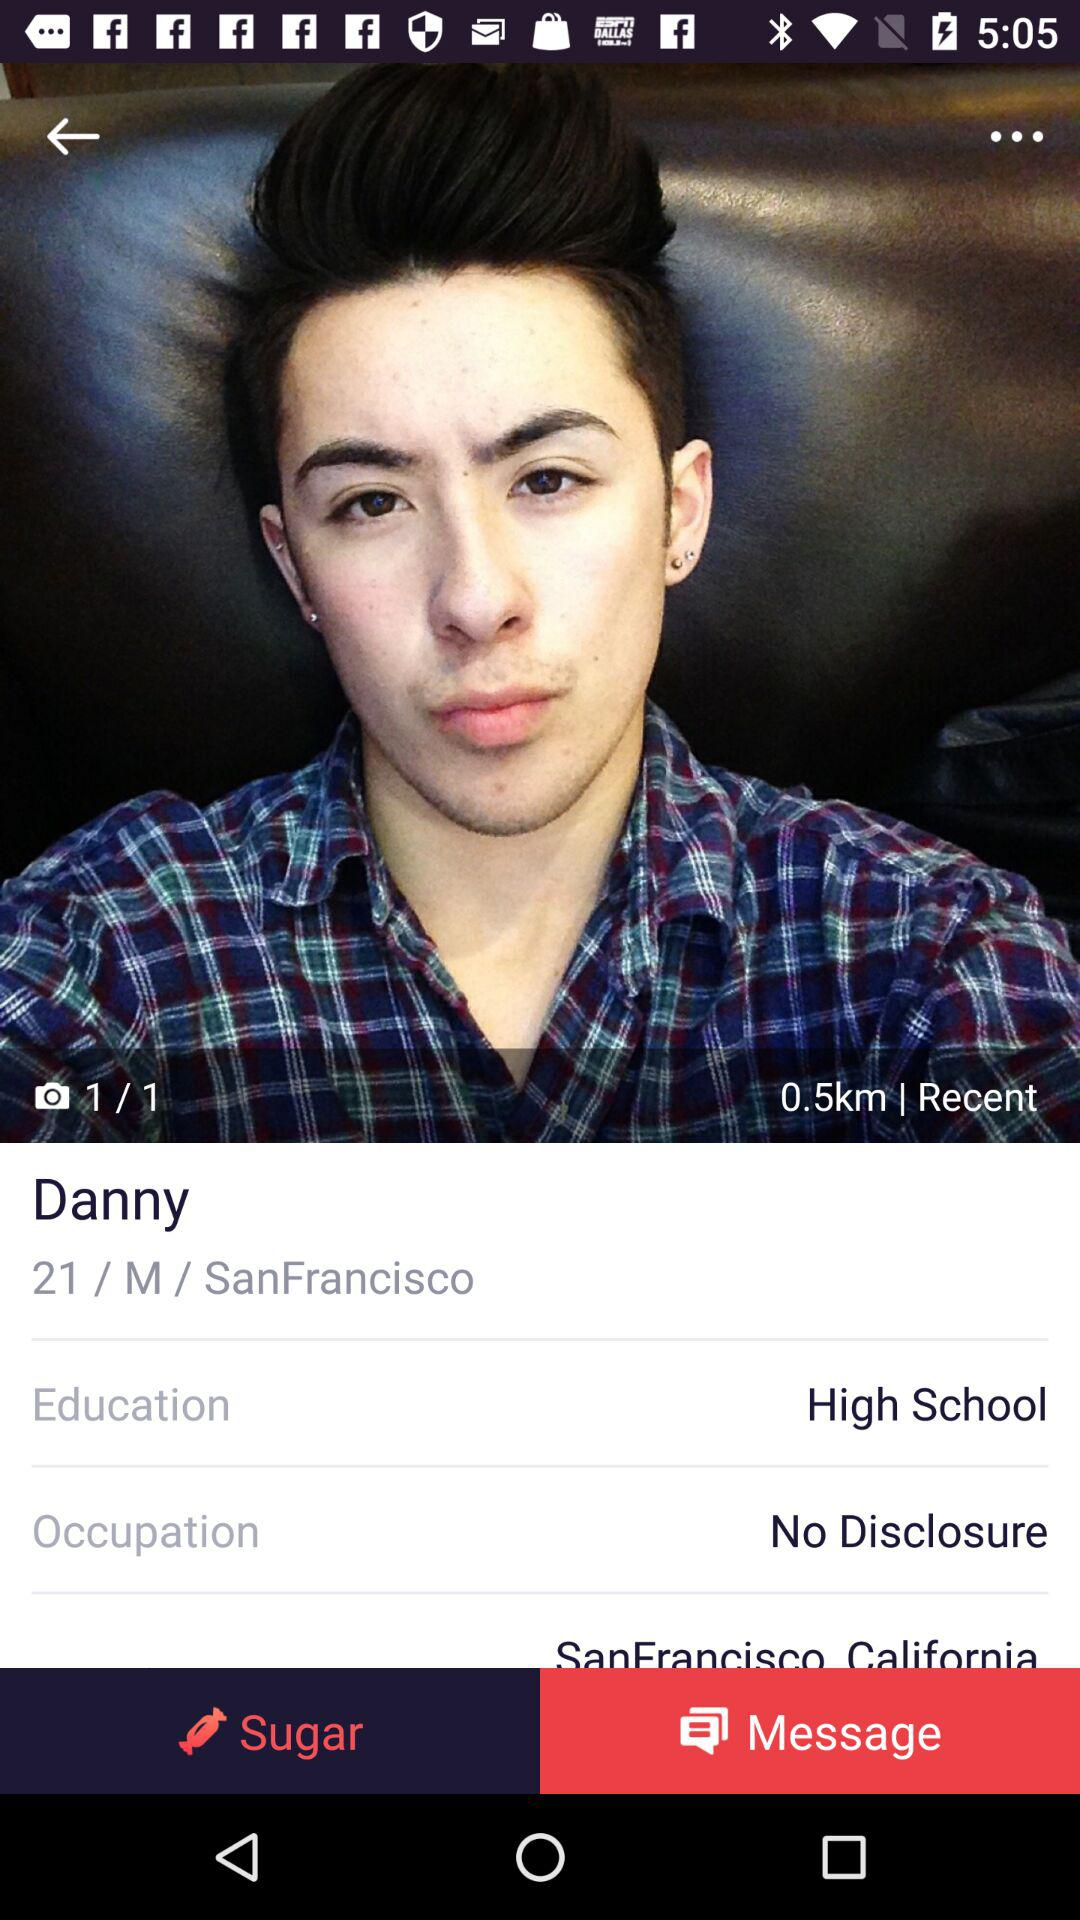What is the age of Danny? The age of Danny is 21. 